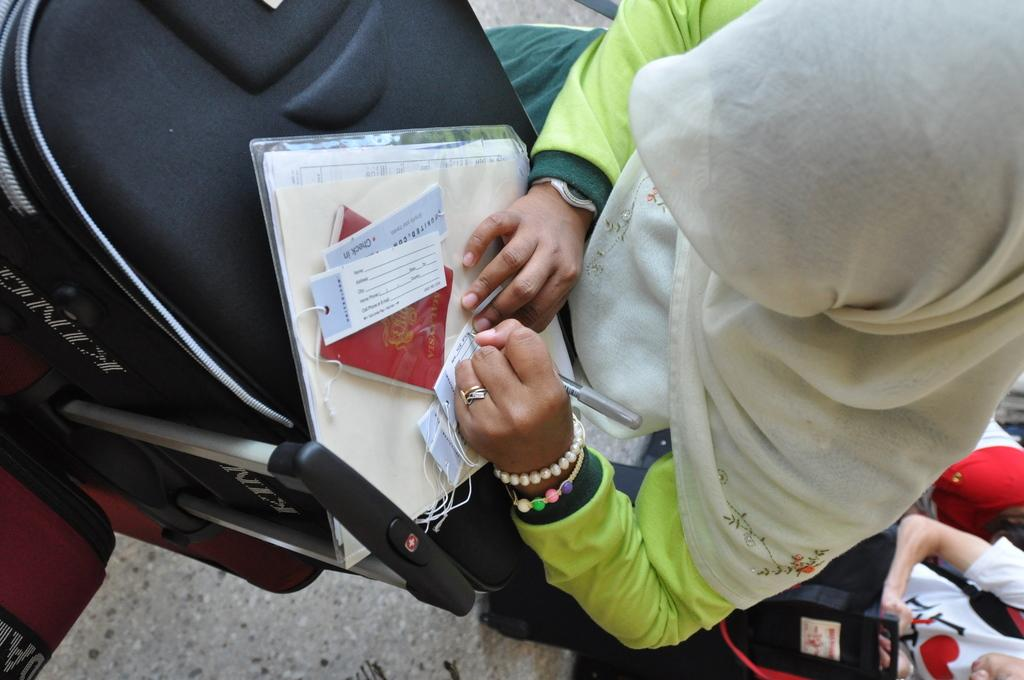How many people are in the image? There is a group of people in the image. Can you describe the woman in the middle of the image? The woman is in the middle of the image, and she is holding a paper. What is the woman doing with the paper? The woman is writing on the paper. What is in front of the woman? There is baggage in front of the woman. What type of railway is visible in the image? There is no railway present in the image. Can you tell me the color of the tank in the image? There is no tank present in the image. 